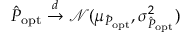Convert formula to latex. <formula><loc_0><loc_0><loc_500><loc_500>\hat { P } _ { o p t } \overset { d } { \to } \mathcal { N } ( \mu _ { \hat { P } _ { o p t } } , \sigma _ { \hat { P } _ { o p t } } ^ { 2 } )</formula> 